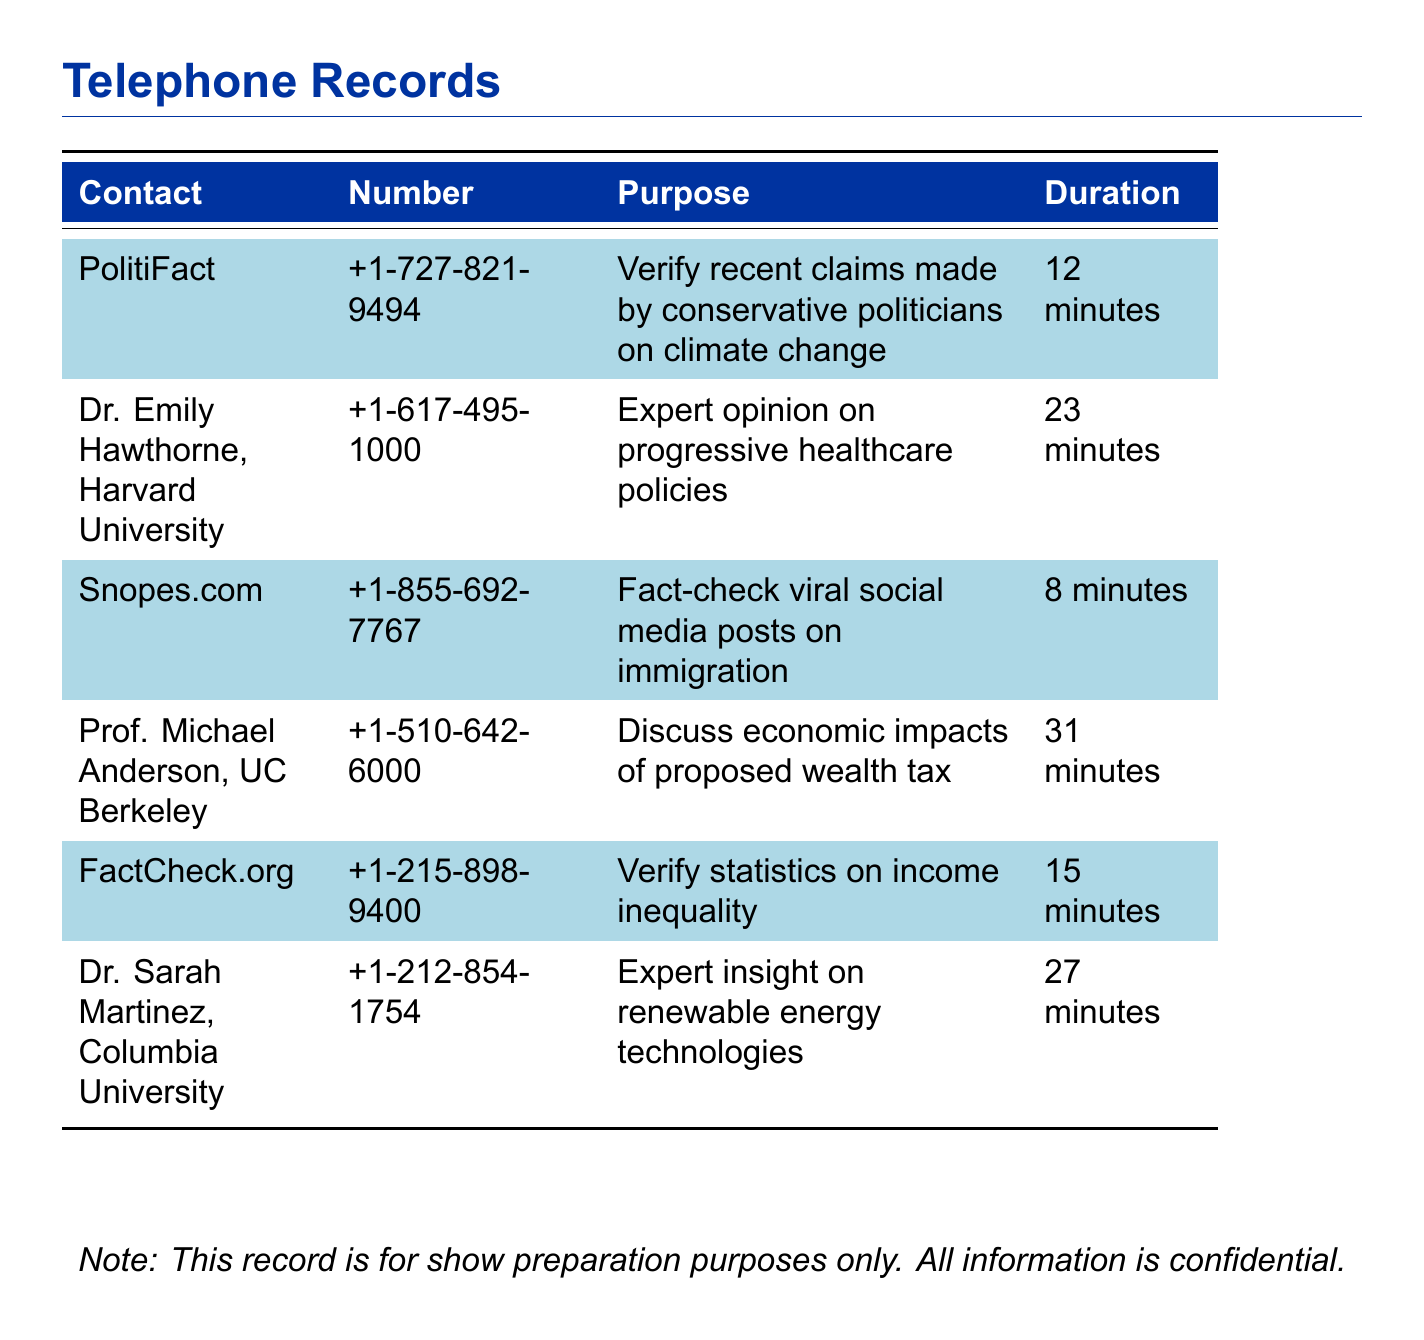What is the contact for PolitiFact? The contact listed for PolitiFact is a phone number in the document.
Answer: +1-727-821-9494 How long was the call with Dr. Emily Hawthorne? The duration of the call is explicitly mentioned in the document next to her name.
Answer: 23 minutes What was the purpose of the call to FactCheck.org? The document states the specific purpose of the call made to FactCheck.org.
Answer: Verify statistics on income inequality Who did you call to discuss economic impacts of proposed wealth tax? The name of the person called for the discussion is listed in the document.
Answer: Prof. Michael Anderson, UC Berkeley What is the total duration of calls made to fact-checking services? This is calculated by adding the durations of the relevant calls in the document.
Answer: 35 minutes Which expert provided insight on renewable energy technologies? The document specifies the name of the expert related to this subject.
Answer: Dr. Sarah Martinez, Columbia University How many minutes did the call with Snopes.com last? The document provides the exact duration of the call with Snopes.com.
Answer: 8 minutes What type of expertise did Dr. Emily Hawthorne offer? The document outlines the area of expertise that Dr. Emily Hawthorne specializes in.
Answer: Progressive healthcare policies What is the color scheme used in the document? The document has a specific color scheme that is mentioned in the formatting settings.
Answer: Progressive blue and light blue 